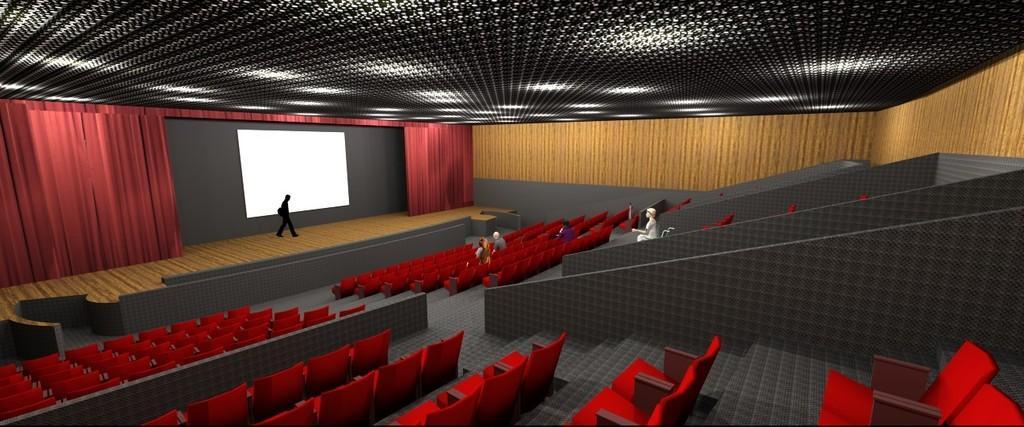Please provide a concise description of this image. Here we can see a graphical image, In this picture we can see chairs in the front, there are some people sitting on chairs, in the background we can see a person is walking, we can also see curtains and a screen in the background. 